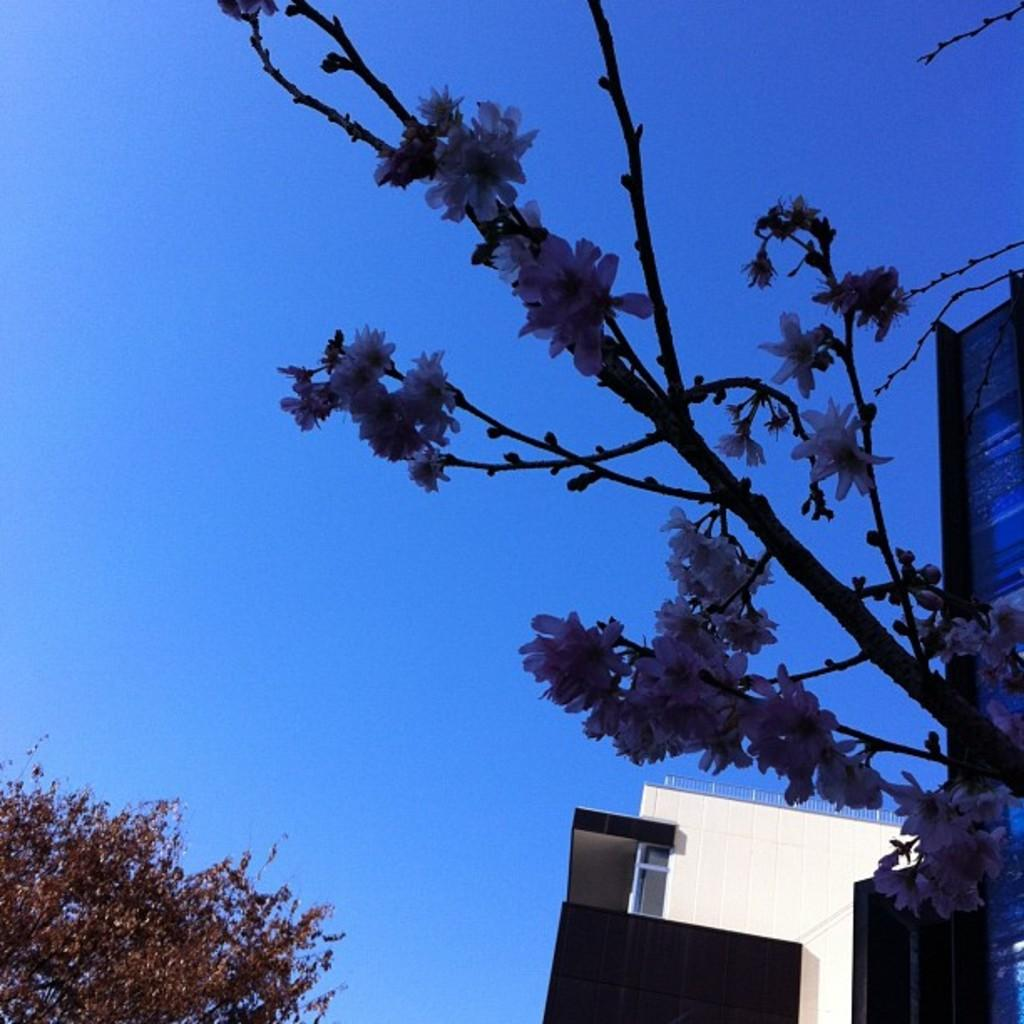What type of plants can be seen in the image? There are flower plants in the image. What can be seen in the background of the image? There is a wall, railings, a glass object, a tree, and the sky visible in the background of the image. What type of dirt is visible on the rail in the image? There is no rail present in the image; it features railings instead. Additionally, there is no dirt visible in the image. 